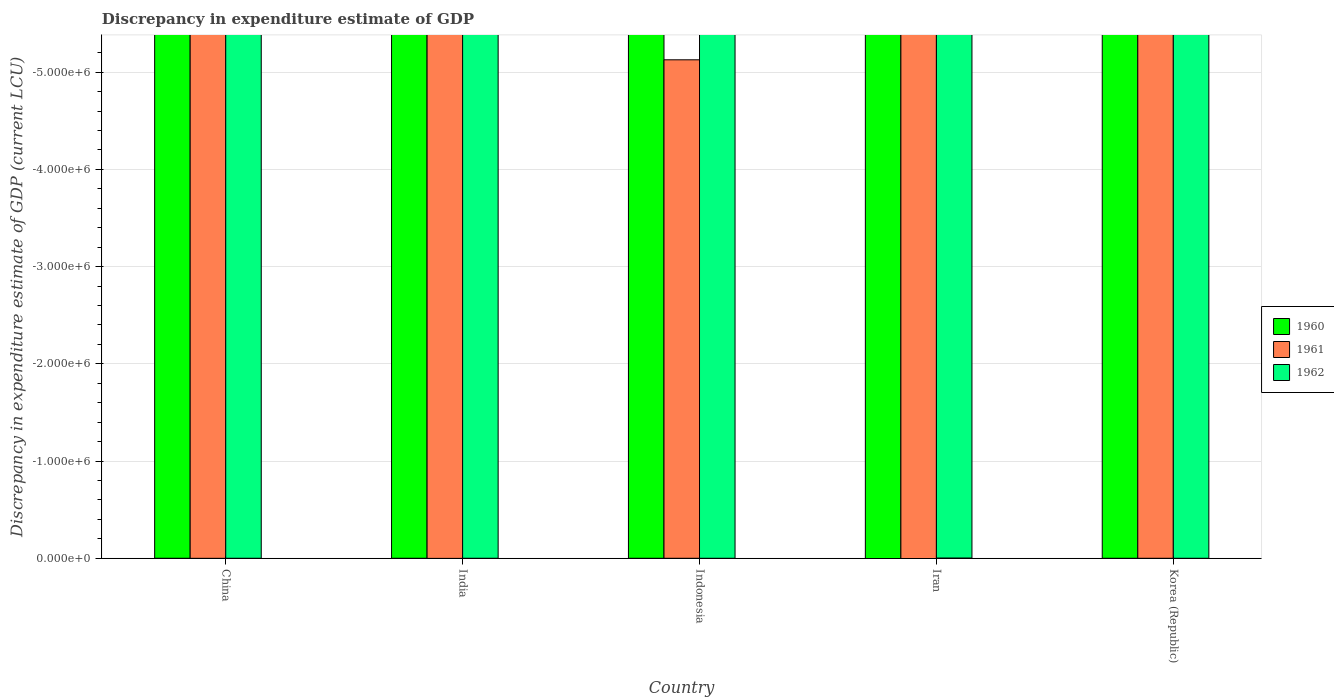How many different coloured bars are there?
Your answer should be very brief. 0. Are the number of bars per tick equal to the number of legend labels?
Give a very brief answer. No. What is the label of the 1st group of bars from the left?
Provide a short and direct response. China. Across all countries, what is the minimum discrepancy in expenditure estimate of GDP in 1961?
Give a very brief answer. 0. What is the total discrepancy in expenditure estimate of GDP in 1960 in the graph?
Your response must be concise. 0. What is the average discrepancy in expenditure estimate of GDP in 1961 per country?
Your response must be concise. 0. In how many countries, is the discrepancy in expenditure estimate of GDP in 1960 greater than -5000000 LCU?
Keep it short and to the point. 0. Is it the case that in every country, the sum of the discrepancy in expenditure estimate of GDP in 1961 and discrepancy in expenditure estimate of GDP in 1960 is greater than the discrepancy in expenditure estimate of GDP in 1962?
Provide a short and direct response. No. Are all the bars in the graph horizontal?
Ensure brevity in your answer.  No. What is the difference between two consecutive major ticks on the Y-axis?
Offer a very short reply. 1.00e+06. Does the graph contain grids?
Your answer should be very brief. Yes. How are the legend labels stacked?
Your answer should be very brief. Vertical. What is the title of the graph?
Provide a short and direct response. Discrepancy in expenditure estimate of GDP. What is the label or title of the Y-axis?
Provide a succinct answer. Discrepancy in expenditure estimate of GDP (current LCU). What is the Discrepancy in expenditure estimate of GDP (current LCU) of 1960 in China?
Ensure brevity in your answer.  0. What is the Discrepancy in expenditure estimate of GDP (current LCU) of 1961 in China?
Give a very brief answer. 0. What is the Discrepancy in expenditure estimate of GDP (current LCU) in 1962 in India?
Offer a very short reply. 0. What is the Discrepancy in expenditure estimate of GDP (current LCU) in 1961 in Indonesia?
Your response must be concise. 0. What is the Discrepancy in expenditure estimate of GDP (current LCU) in 1962 in Indonesia?
Provide a short and direct response. 0. What is the Discrepancy in expenditure estimate of GDP (current LCU) in 1960 in Iran?
Offer a terse response. 0. What is the Discrepancy in expenditure estimate of GDP (current LCU) of 1960 in Korea (Republic)?
Your answer should be very brief. 0. What is the total Discrepancy in expenditure estimate of GDP (current LCU) in 1960 in the graph?
Provide a succinct answer. 0. What is the average Discrepancy in expenditure estimate of GDP (current LCU) in 1960 per country?
Provide a succinct answer. 0. What is the average Discrepancy in expenditure estimate of GDP (current LCU) in 1961 per country?
Give a very brief answer. 0. What is the average Discrepancy in expenditure estimate of GDP (current LCU) of 1962 per country?
Your response must be concise. 0. 